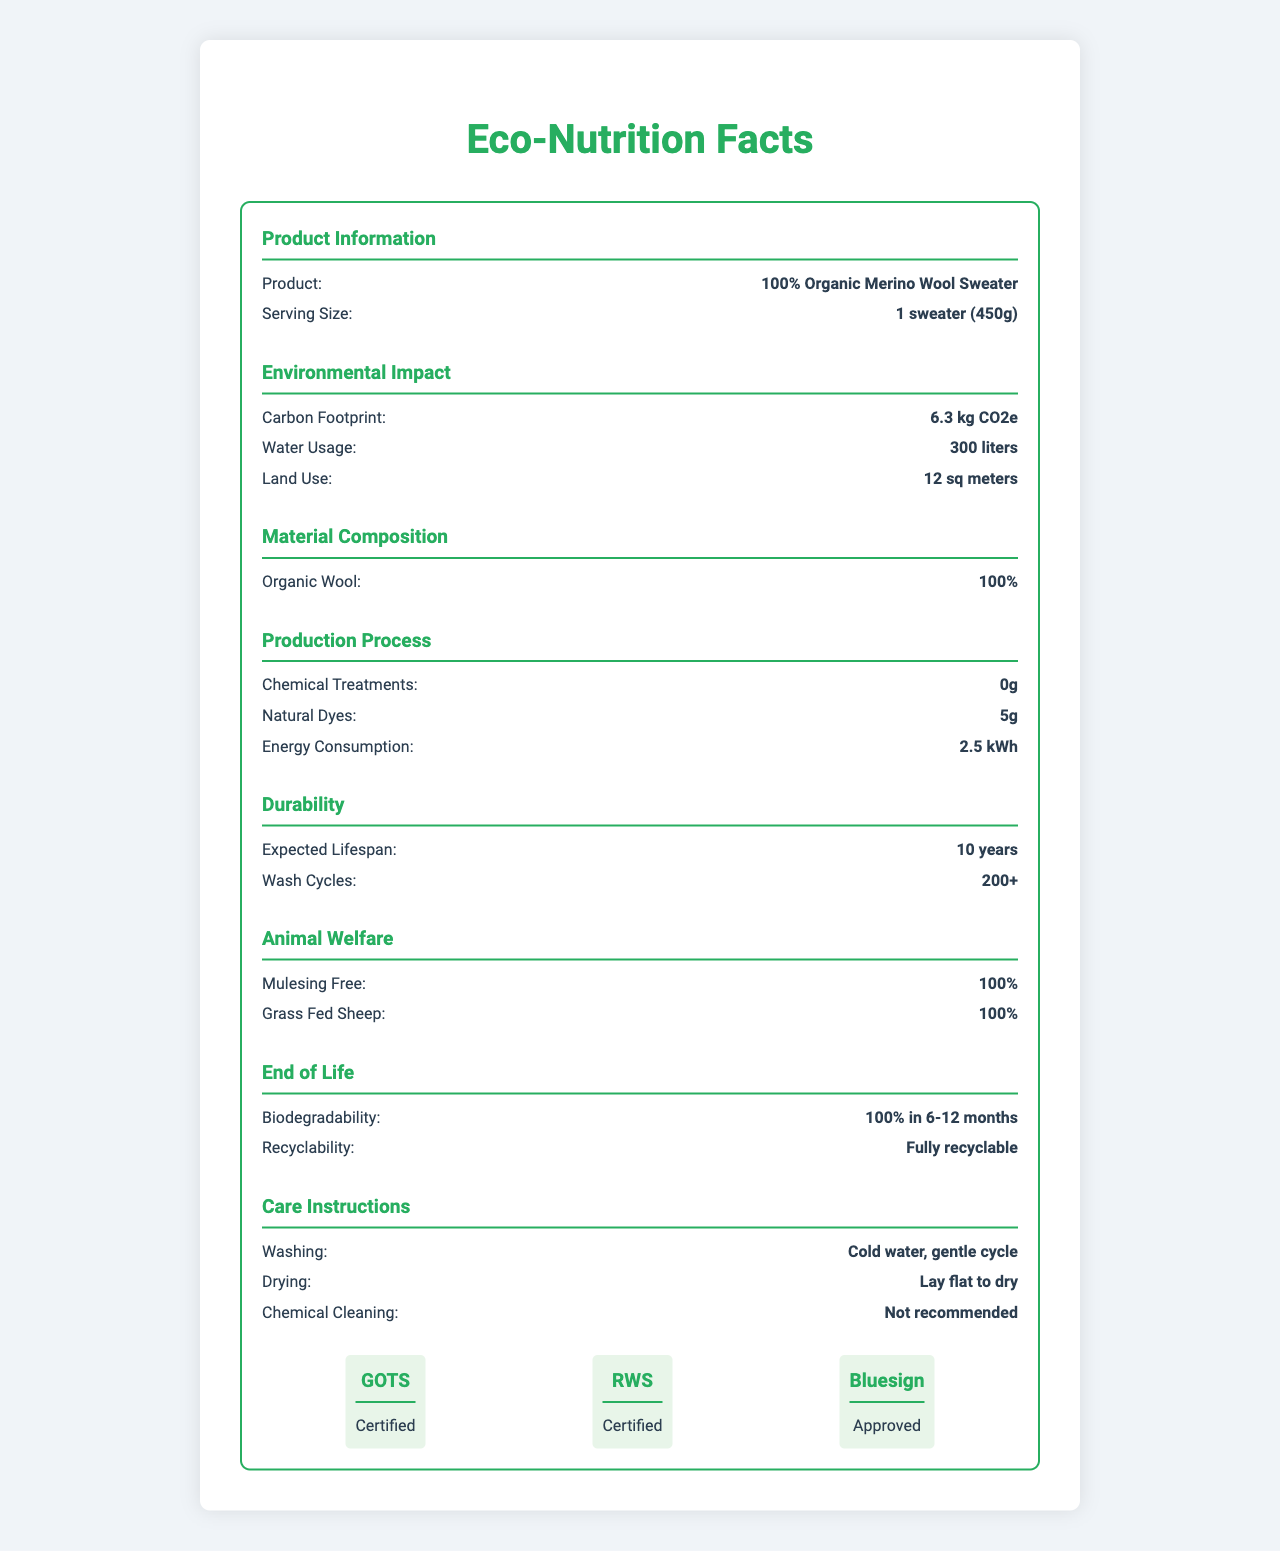what is the carbon footprint of the 100% Organic Merino Wool Sweater? The document states that the carbon footprint of the sweater is 6.3 kg CO2e under the Environmental Impact section.
Answer: 6.3 kg CO2e what is the expected lifespan of the sweater? The document mentions that the expected lifespan of the sweater is 10 years under the Durability section.
Answer: 10 years how much water is used for the production of one 100% Organic Merino Wool Sweater? The document lists water usage as 300 liters under Environmental Impact.
Answer: 300 liters what are the washing instructions for the sweater? The Care Instructions section specifies that the sweater should be washed with cold water on a gentle cycle.
Answer: Cold water, gentle cycle what certifications does the sweater have? The document shows that the sweater is certified by GOTS, RWS, and Bluesign under the Certifications section.
Answer: Global Organic Textile Standard (GOTS), Responsible Wool Standard (RWS), Bluesign what type of material is the 100% Organic Merino Wool Sweater made from? A. Synthetic material B. Cotton C. Organic wool The material composition is stated to be 100% organic wool under Material Composition.
Answer: C how long does it take for the sweater to biodegrade? A. 1-3 months B. 6-12 months C. 18-24 months D. Not biodegradable The document states that the sweater is 100% biodegradable in 6-12 months under the End of Life section.
Answer: B is the sweater made with any synthetic materials? Under Material Composition, it is stated that the sweater contains 0% synthetic materials.
Answer: No are chemical treatments used in the production process of the sweater? The Production Process section specifies that there are 0g of chemical treatments used.
Answer: No does the sweater comply with fair labor practices? The Social Impact section states 100% compliance with fair labor practices.
Answer: Yes summarize the environmental impact information of the 100% Organic Merino Wool Sweater. The Environmental Impact section provides these metrics, showing a focus on sustainability.
Answer: The sweater has a low environmental impact, with a carbon footprint of 6.3 kg CO2e, water usage of 300 liters, and land use of 12 sq meters. how many wash cycles can the sweater endure? The Durability section mentions that the sweater can withstand 200+ wash cycles.
Answer: 200+ what is the main dyeing method used for the 100% Organic Merino Wool Sweater? The Production Process section indicates that natural dyes are used, totaling 5g.
Answer: Natural dyes what is the shipping distance for the sweater? The Transportation section states that the shipping distance is 500 km.
Answer: 500 km how many jobs does the production of the sweater create locally? The Social Impact section states that 25 jobs were created through local employment.
Answer: 25 what is the lifespan of recycled content in the 100% Organic Merino Wool Sweater? The document does not mention the lifespan of recycled content specifically.
Answer: Not enough information 